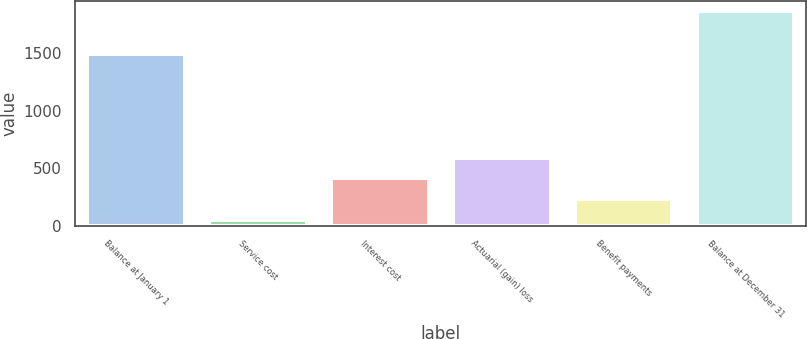<chart> <loc_0><loc_0><loc_500><loc_500><bar_chart><fcel>Balance at January 1<fcel>Service cost<fcel>Interest cost<fcel>Actuarial (gain) loss<fcel>Benefit payments<fcel>Balance at December 31<nl><fcel>1497<fcel>49<fcel>412.4<fcel>594.1<fcel>230.7<fcel>1866<nl></chart> 